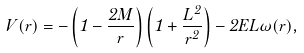Convert formula to latex. <formula><loc_0><loc_0><loc_500><loc_500>V ( r ) = - \left ( 1 - \frac { 2 M } { r } \right ) \left ( 1 + \frac { L ^ { 2 } } { r ^ { 2 } } \right ) - 2 E L \omega ( r ) ,</formula> 